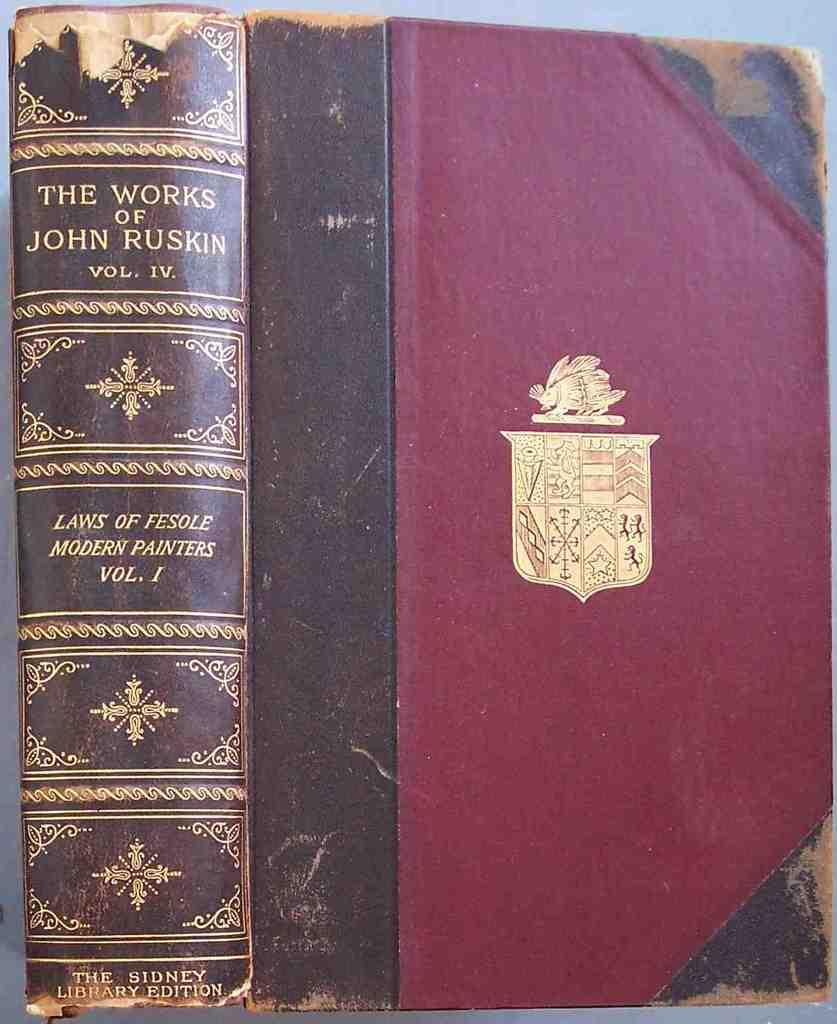<image>
Write a terse but informative summary of the picture. A worn copy of The Works of John Ruskin volume IV. 